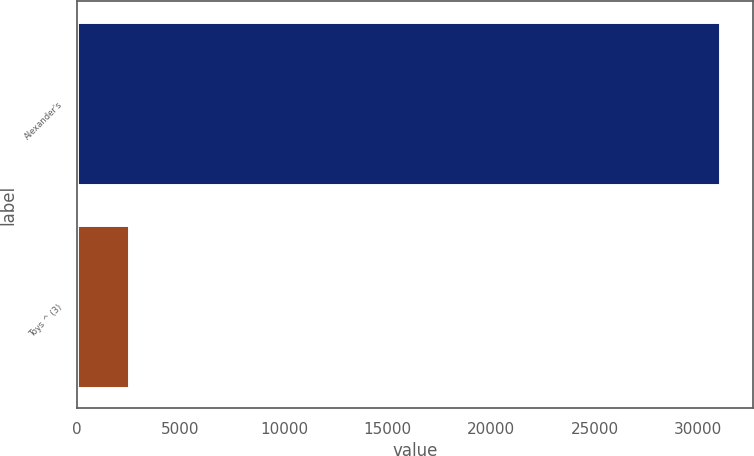Convert chart to OTSL. <chart><loc_0><loc_0><loc_500><loc_500><bar_chart><fcel>Alexander's<fcel>Toys ^ (3)<nl><fcel>31078<fcel>2500<nl></chart> 